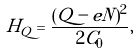Convert formula to latex. <formula><loc_0><loc_0><loc_500><loc_500>H _ { Q } = \frac { ( Q - e N ) ^ { 2 } } { 2 C _ { 0 } } ,</formula> 